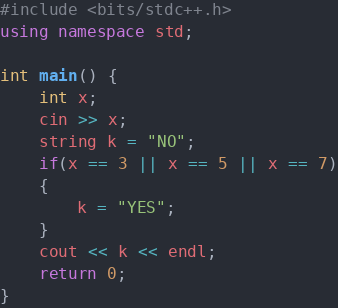<code> <loc_0><loc_0><loc_500><loc_500><_C++_>#include <bits/stdc++.h>
using namespace std;

int main() {
	int x;
	cin >> x;
	string k = "NO";
	if(x == 3 || x == 5 || x == 7)
	{
		k = "YES";
	}
	cout << k << endl;
	return 0;
}
</code> 